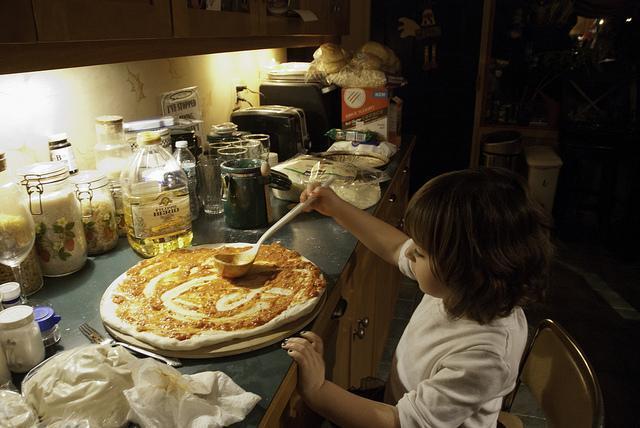How many bottles are visible?
Give a very brief answer. 2. 